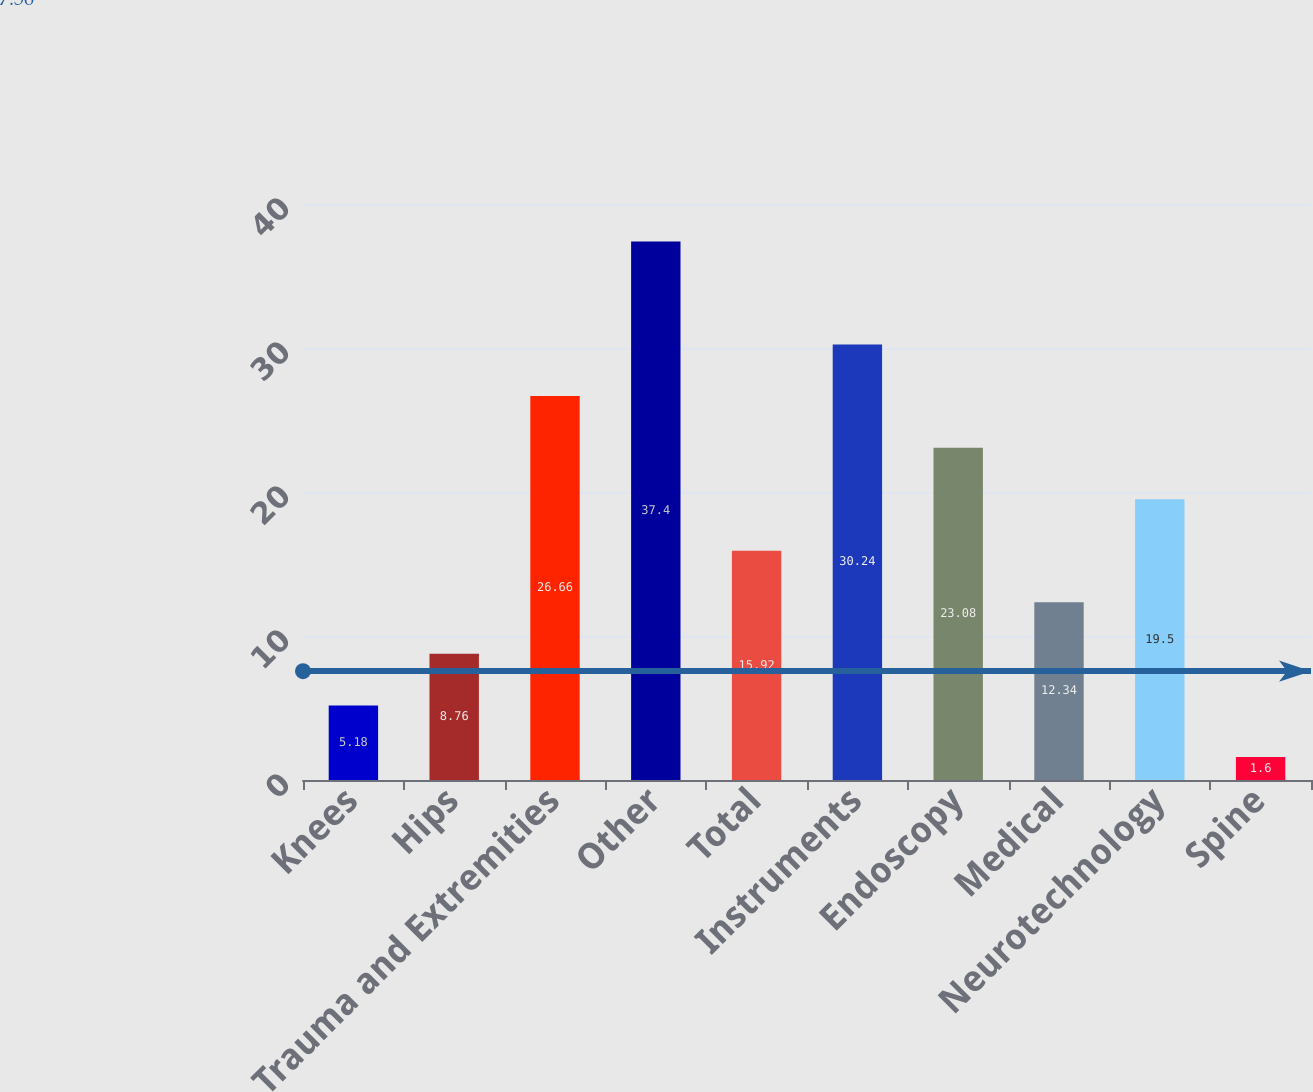<chart> <loc_0><loc_0><loc_500><loc_500><bar_chart><fcel>Knees<fcel>Hips<fcel>Trauma and Extremities<fcel>Other<fcel>Total<fcel>Instruments<fcel>Endoscopy<fcel>Medical<fcel>Neurotechnology<fcel>Spine<nl><fcel>5.18<fcel>8.76<fcel>26.66<fcel>37.4<fcel>15.92<fcel>30.24<fcel>23.08<fcel>12.34<fcel>19.5<fcel>1.6<nl></chart> 